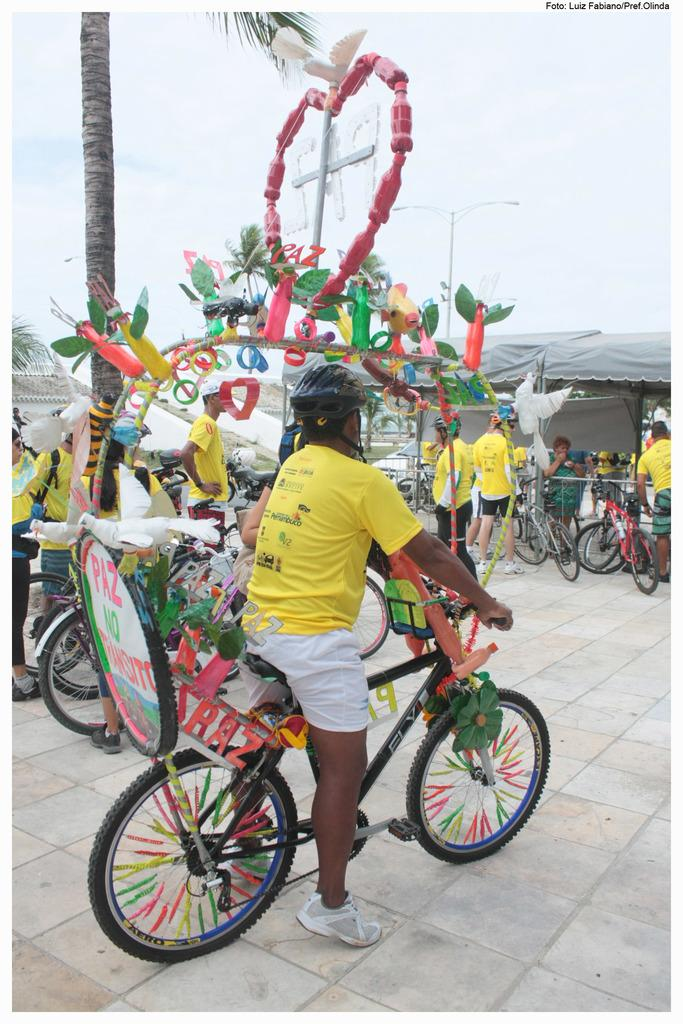Who or what can be seen in the image? There are people in the image. What objects are associated with the people in the image? There are bicycles in the image. What structures are present in the image? There are poles and tents in the image. What type of vegetation is visible in the image? There is a tree in the image. What is visible in the background of the image? The sky is visible in the background of the image. What type of cream can be seen on the snails in the image? There are no snails present in the image, and therefore no cream can be observed on them. 